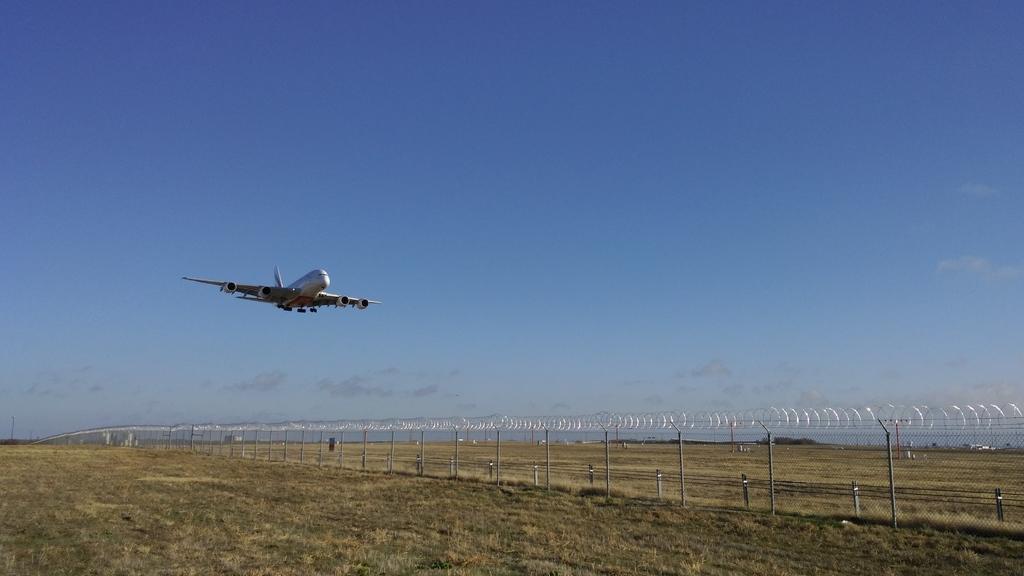Can you describe this image briefly? In the middle of the image I can see an airplane. At the top of the image I can see blue sky. On the right of the image I can see some electrical wires. 